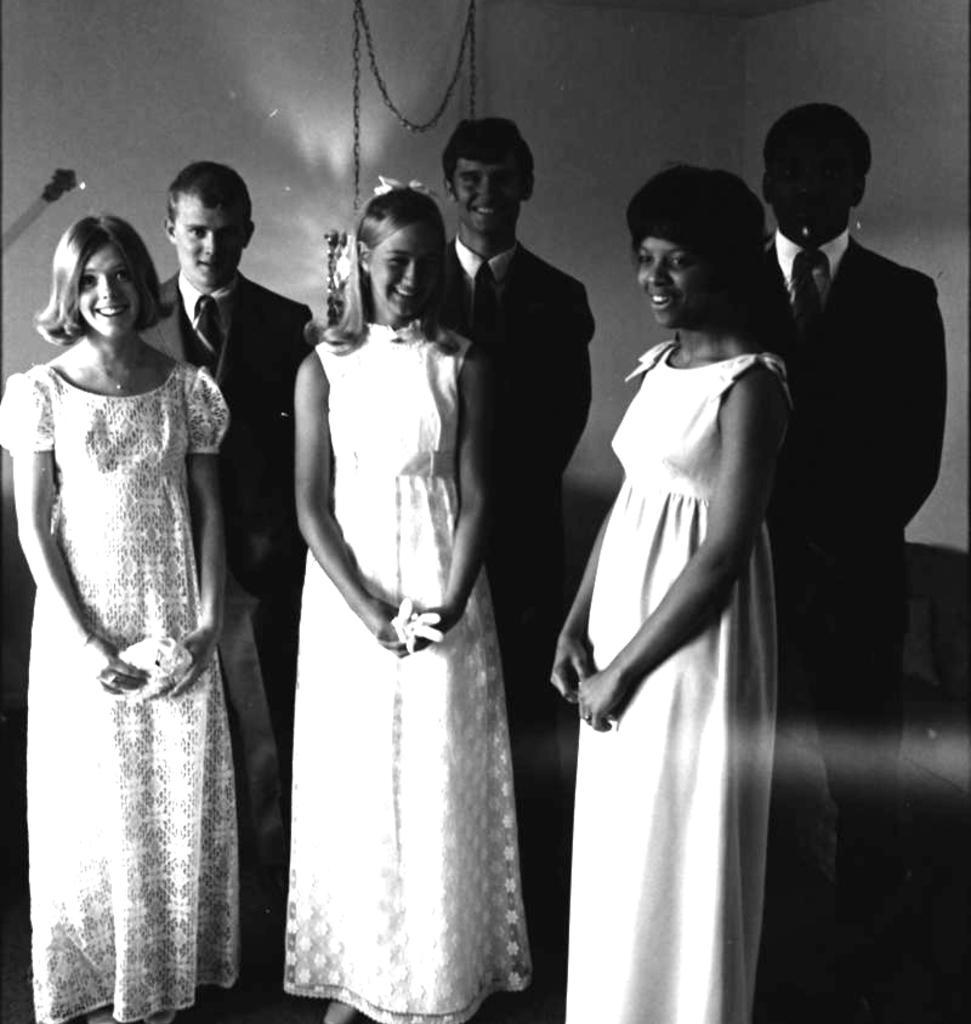Could you give a brief overview of what you see in this image? This is a black and white picture. Here we can see few persons. In the background there is a wall. 